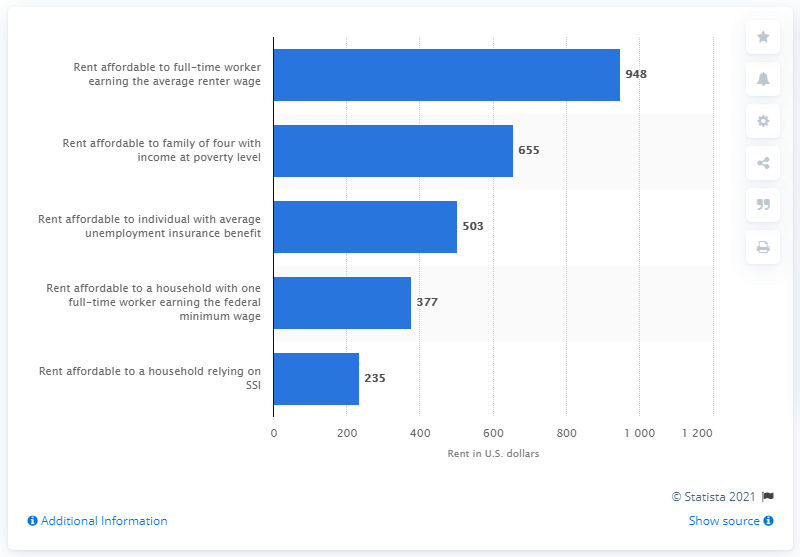Specify some key components in this picture. In 2020, the average monthly rent that was affordable for a family of four with a household income at the poverty line was 655. 